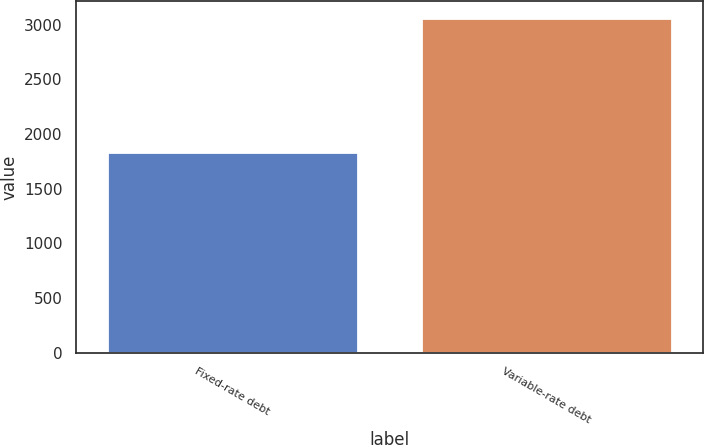Convert chart to OTSL. <chart><loc_0><loc_0><loc_500><loc_500><bar_chart><fcel>Fixed-rate debt<fcel>Variable-rate debt<nl><fcel>1838<fcel>3062<nl></chart> 